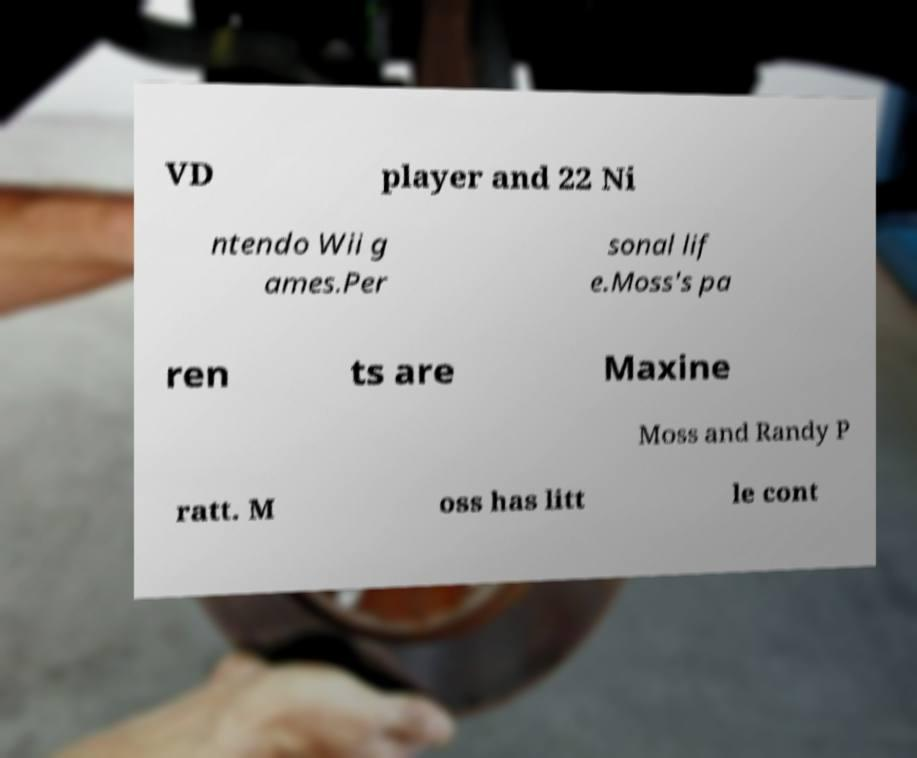Can you read and provide the text displayed in the image?This photo seems to have some interesting text. Can you extract and type it out for me? VD player and 22 Ni ntendo Wii g ames.Per sonal lif e.Moss's pa ren ts are Maxine Moss and Randy P ratt. M oss has litt le cont 